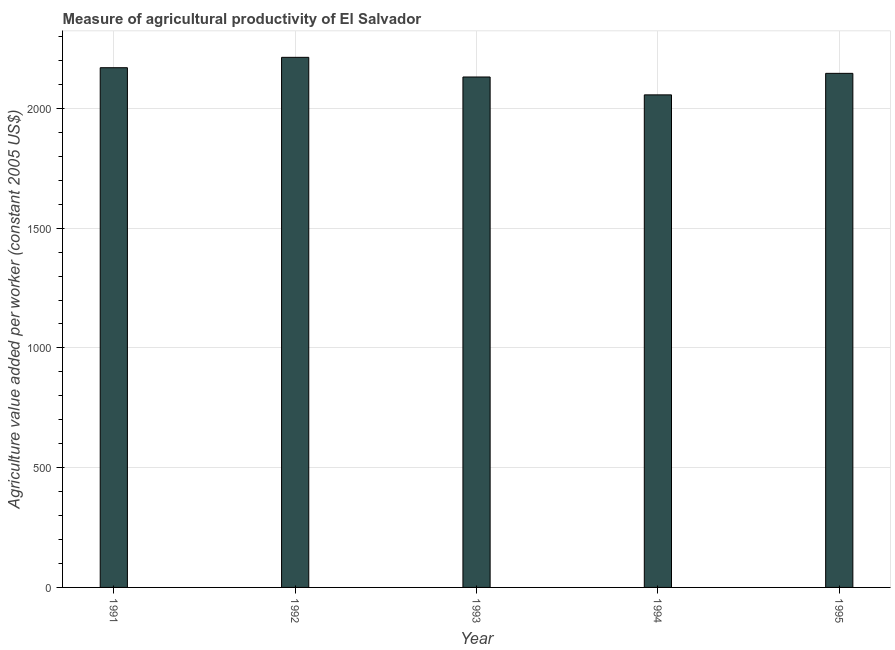Does the graph contain grids?
Your answer should be compact. Yes. What is the title of the graph?
Give a very brief answer. Measure of agricultural productivity of El Salvador. What is the label or title of the Y-axis?
Your answer should be very brief. Agriculture value added per worker (constant 2005 US$). What is the agriculture value added per worker in 1995?
Keep it short and to the point. 2146.31. Across all years, what is the maximum agriculture value added per worker?
Provide a succinct answer. 2213.23. Across all years, what is the minimum agriculture value added per worker?
Make the answer very short. 2056.51. In which year was the agriculture value added per worker maximum?
Your answer should be compact. 1992. What is the sum of the agriculture value added per worker?
Make the answer very short. 1.07e+04. What is the difference between the agriculture value added per worker in 1991 and 1992?
Your answer should be very brief. -43.37. What is the average agriculture value added per worker per year?
Provide a short and direct response. 2143.4. What is the median agriculture value added per worker?
Your response must be concise. 2146.31. In how many years, is the agriculture value added per worker greater than 300 US$?
Give a very brief answer. 5. Do a majority of the years between 1993 and 1992 (inclusive) have agriculture value added per worker greater than 800 US$?
Provide a short and direct response. No. What is the ratio of the agriculture value added per worker in 1992 to that in 1993?
Your answer should be compact. 1.04. Is the agriculture value added per worker in 1991 less than that in 1992?
Keep it short and to the point. Yes. What is the difference between the highest and the second highest agriculture value added per worker?
Your answer should be compact. 43.37. Is the sum of the agriculture value added per worker in 1992 and 1993 greater than the maximum agriculture value added per worker across all years?
Provide a succinct answer. Yes. What is the difference between the highest and the lowest agriculture value added per worker?
Your answer should be compact. 156.72. In how many years, is the agriculture value added per worker greater than the average agriculture value added per worker taken over all years?
Keep it short and to the point. 3. How many bars are there?
Provide a succinct answer. 5. How many years are there in the graph?
Offer a very short reply. 5. What is the difference between two consecutive major ticks on the Y-axis?
Your answer should be compact. 500. What is the Agriculture value added per worker (constant 2005 US$) of 1991?
Keep it short and to the point. 2169.86. What is the Agriculture value added per worker (constant 2005 US$) in 1992?
Your response must be concise. 2213.23. What is the Agriculture value added per worker (constant 2005 US$) in 1993?
Make the answer very short. 2131.11. What is the Agriculture value added per worker (constant 2005 US$) of 1994?
Offer a very short reply. 2056.51. What is the Agriculture value added per worker (constant 2005 US$) in 1995?
Provide a succinct answer. 2146.31. What is the difference between the Agriculture value added per worker (constant 2005 US$) in 1991 and 1992?
Your answer should be compact. -43.37. What is the difference between the Agriculture value added per worker (constant 2005 US$) in 1991 and 1993?
Ensure brevity in your answer.  38.74. What is the difference between the Agriculture value added per worker (constant 2005 US$) in 1991 and 1994?
Offer a terse response. 113.35. What is the difference between the Agriculture value added per worker (constant 2005 US$) in 1991 and 1995?
Make the answer very short. 23.55. What is the difference between the Agriculture value added per worker (constant 2005 US$) in 1992 and 1993?
Give a very brief answer. 82.12. What is the difference between the Agriculture value added per worker (constant 2005 US$) in 1992 and 1994?
Offer a very short reply. 156.72. What is the difference between the Agriculture value added per worker (constant 2005 US$) in 1992 and 1995?
Ensure brevity in your answer.  66.92. What is the difference between the Agriculture value added per worker (constant 2005 US$) in 1993 and 1994?
Provide a succinct answer. 74.61. What is the difference between the Agriculture value added per worker (constant 2005 US$) in 1993 and 1995?
Your answer should be compact. -15.2. What is the difference between the Agriculture value added per worker (constant 2005 US$) in 1994 and 1995?
Make the answer very short. -89.8. What is the ratio of the Agriculture value added per worker (constant 2005 US$) in 1991 to that in 1992?
Your answer should be very brief. 0.98. What is the ratio of the Agriculture value added per worker (constant 2005 US$) in 1991 to that in 1994?
Offer a terse response. 1.05. What is the ratio of the Agriculture value added per worker (constant 2005 US$) in 1992 to that in 1993?
Provide a succinct answer. 1.04. What is the ratio of the Agriculture value added per worker (constant 2005 US$) in 1992 to that in 1994?
Your answer should be very brief. 1.08. What is the ratio of the Agriculture value added per worker (constant 2005 US$) in 1992 to that in 1995?
Offer a terse response. 1.03. What is the ratio of the Agriculture value added per worker (constant 2005 US$) in 1993 to that in 1994?
Ensure brevity in your answer.  1.04. What is the ratio of the Agriculture value added per worker (constant 2005 US$) in 1994 to that in 1995?
Keep it short and to the point. 0.96. 